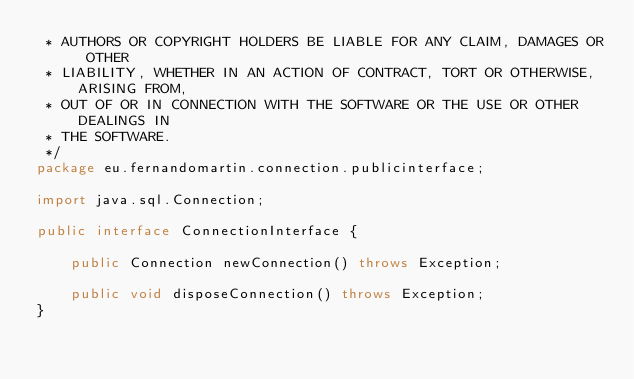Convert code to text. <code><loc_0><loc_0><loc_500><loc_500><_Java_> * AUTHORS OR COPYRIGHT HOLDERS BE LIABLE FOR ANY CLAIM, DAMAGES OR OTHER
 * LIABILITY, WHETHER IN AN ACTION OF CONTRACT, TORT OR OTHERWISE, ARISING FROM,
 * OUT OF OR IN CONNECTION WITH THE SOFTWARE OR THE USE OR OTHER DEALINGS IN
 * THE SOFTWARE.
 */
package eu.fernandomartin.connection.publicinterface;

import java.sql.Connection;

public interface ConnectionInterface {

    public Connection newConnection() throws Exception;

    public void disposeConnection() throws Exception;
}
</code> 